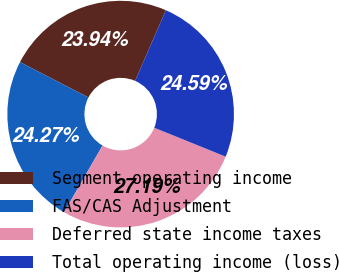Convert chart to OTSL. <chart><loc_0><loc_0><loc_500><loc_500><pie_chart><fcel>Segment operating income<fcel>FAS/CAS Adjustment<fcel>Deferred state income taxes<fcel>Total operating income (loss)<nl><fcel>23.94%<fcel>24.27%<fcel>27.19%<fcel>24.59%<nl></chart> 